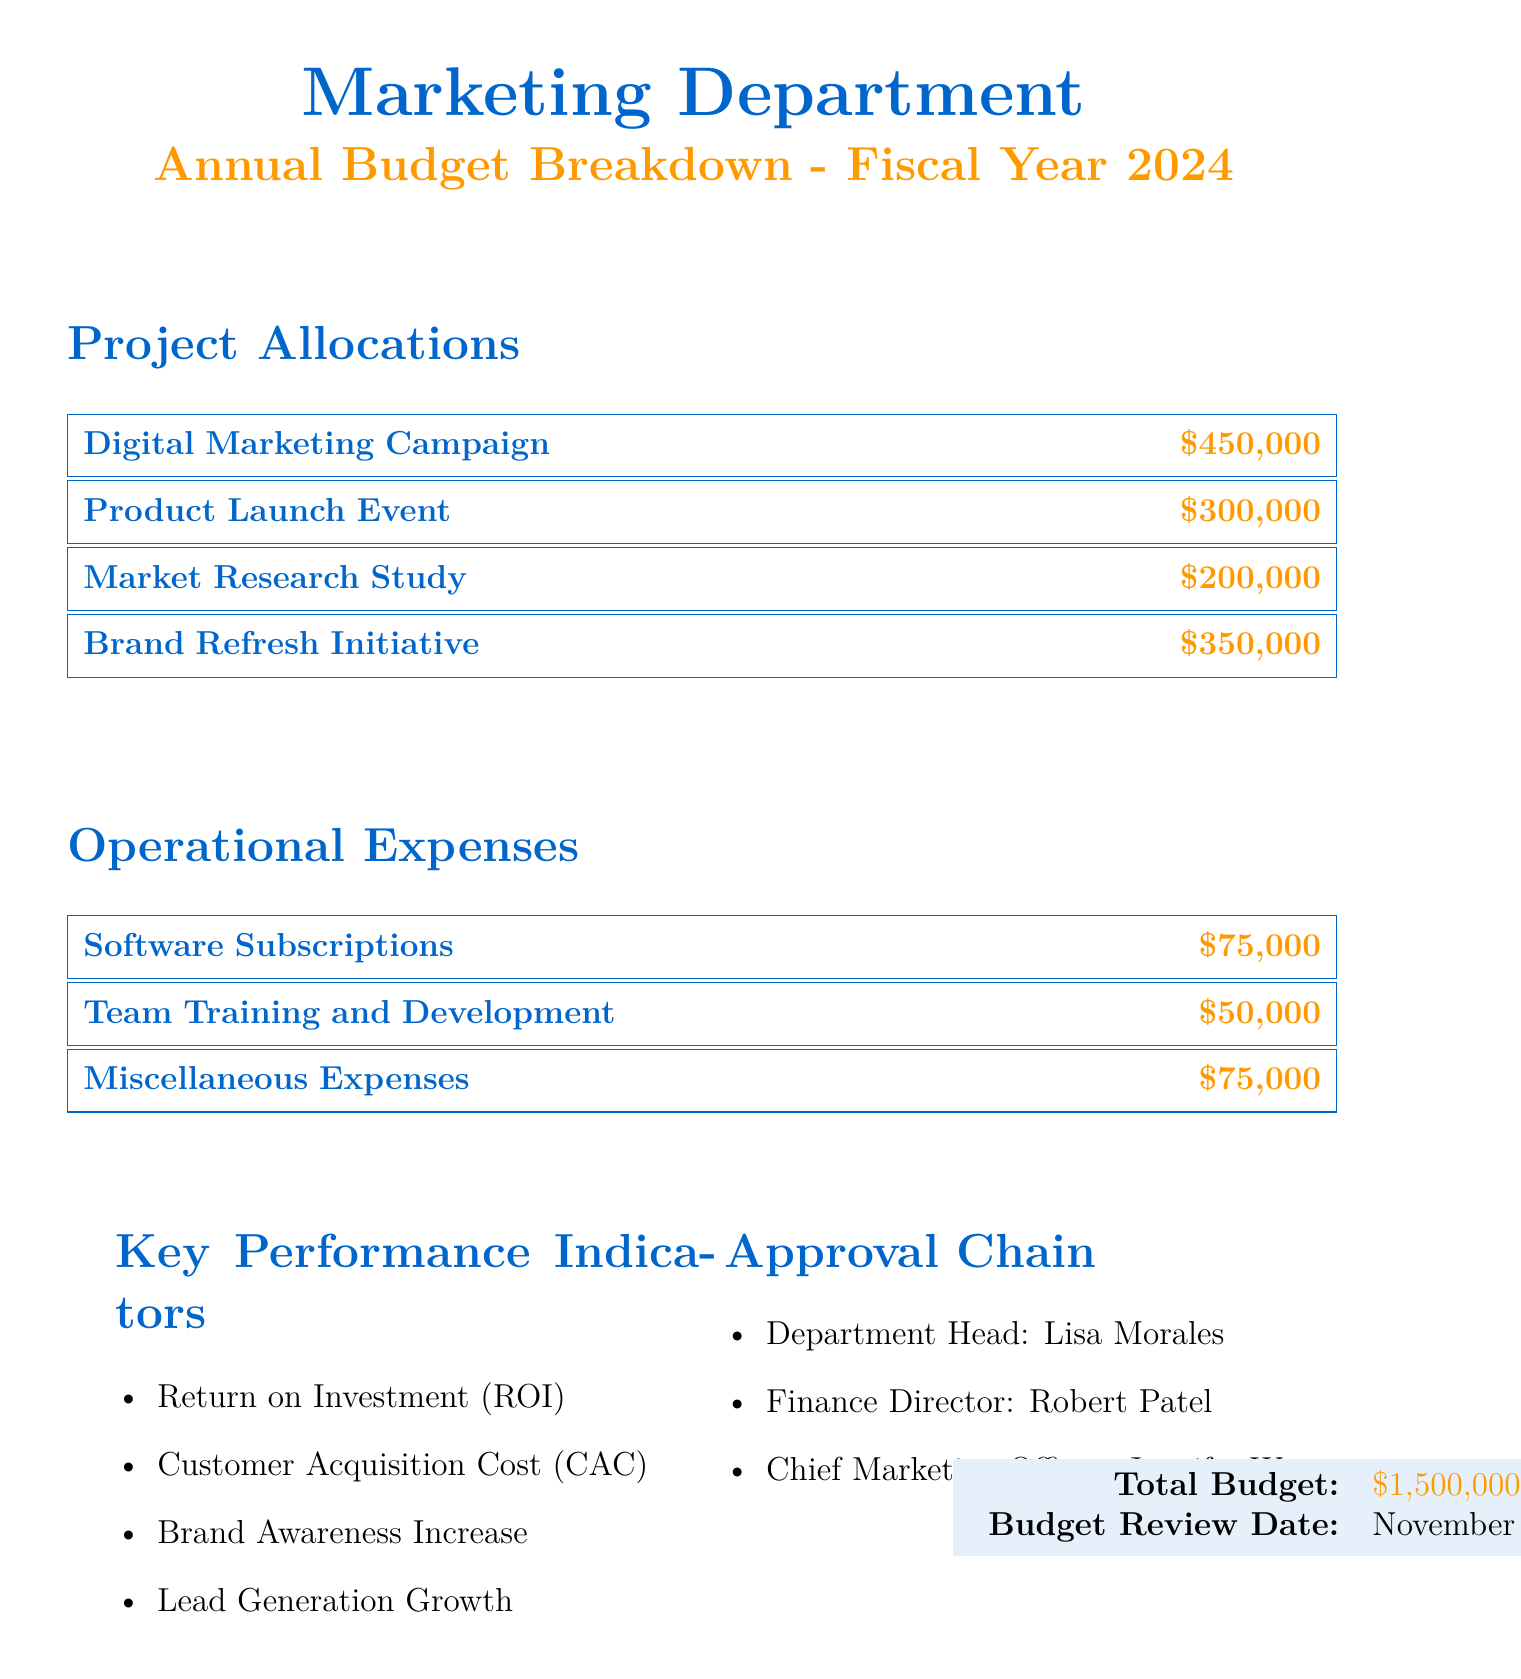What is the total budget? The total budget is presented at the bottom of the document, summarizing the entire allocation for the department.
Answer: $1,500,000 Who is the department head? The document lists the department head under the approval chain section.
Answer: Lisa Morales How much is allocated for the Digital Marketing Campaign? The allocation for the Digital Marketing Campaign is specifically listed in the project allocations section.
Answer: $450,000 What is the budget for team training and development? The budget for team training and development can be found in the operational expenses section.
Answer: $50,000 What is the date for the budget review? The budget review date is mentioned alongside the total budget at the bottom of the document.
Answer: November 15, 2023 Which project has the lowest funding? By comparing the amounts listed for each project, we can determine which project has the lowest funding.
Answer: Market Research Study What are the key performance indicators? The document includes a list of key performance indicators that will be used to measure success, found in a specific section.
Answer: Return on Investment (ROI), Customer Acquisition Cost (CAC), Brand Awareness Increase, Lead Generation Growth How much is allocated for miscellaneous expenses? The allocation for miscellaneous expenses is detailed in the operational expenses section of the document.
Answer: $75,000 Who is the Chief Marketing Officer? The Chief Marketing Officer is listed in the approval chain, indicating their role in the budget approval process.
Answer: Jennifer Wu 